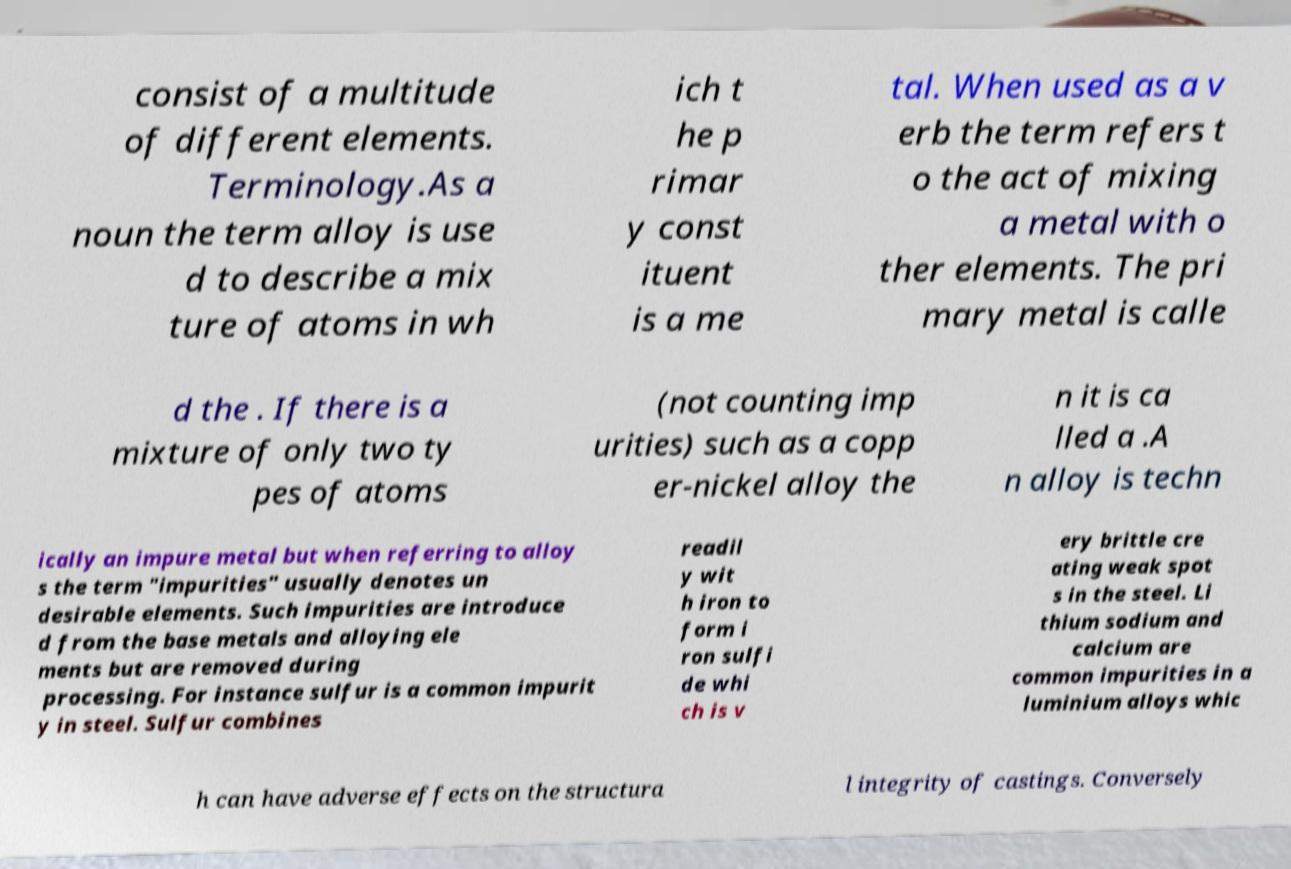There's text embedded in this image that I need extracted. Can you transcribe it verbatim? consist of a multitude of different elements. Terminology.As a noun the term alloy is use d to describe a mix ture of atoms in wh ich t he p rimar y const ituent is a me tal. When used as a v erb the term refers t o the act of mixing a metal with o ther elements. The pri mary metal is calle d the . If there is a mixture of only two ty pes of atoms (not counting imp urities) such as a copp er-nickel alloy the n it is ca lled a .A n alloy is techn ically an impure metal but when referring to alloy s the term "impurities" usually denotes un desirable elements. Such impurities are introduce d from the base metals and alloying ele ments but are removed during processing. For instance sulfur is a common impurit y in steel. Sulfur combines readil y wit h iron to form i ron sulfi de whi ch is v ery brittle cre ating weak spot s in the steel. Li thium sodium and calcium are common impurities in a luminium alloys whic h can have adverse effects on the structura l integrity of castings. Conversely 